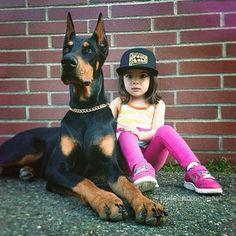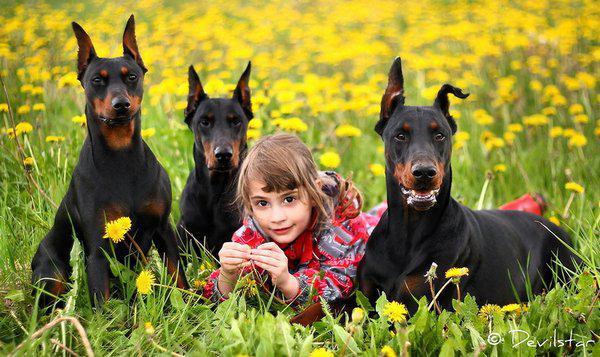The first image is the image on the left, the second image is the image on the right. Examine the images to the left and right. Is the description "A young girl is sitting next to her doberman pincer." accurate? Answer yes or no. Yes. The first image is the image on the left, the second image is the image on the right. Examine the images to the left and right. Is the description "There are at least three dogs in total." accurate? Answer yes or no. Yes. 